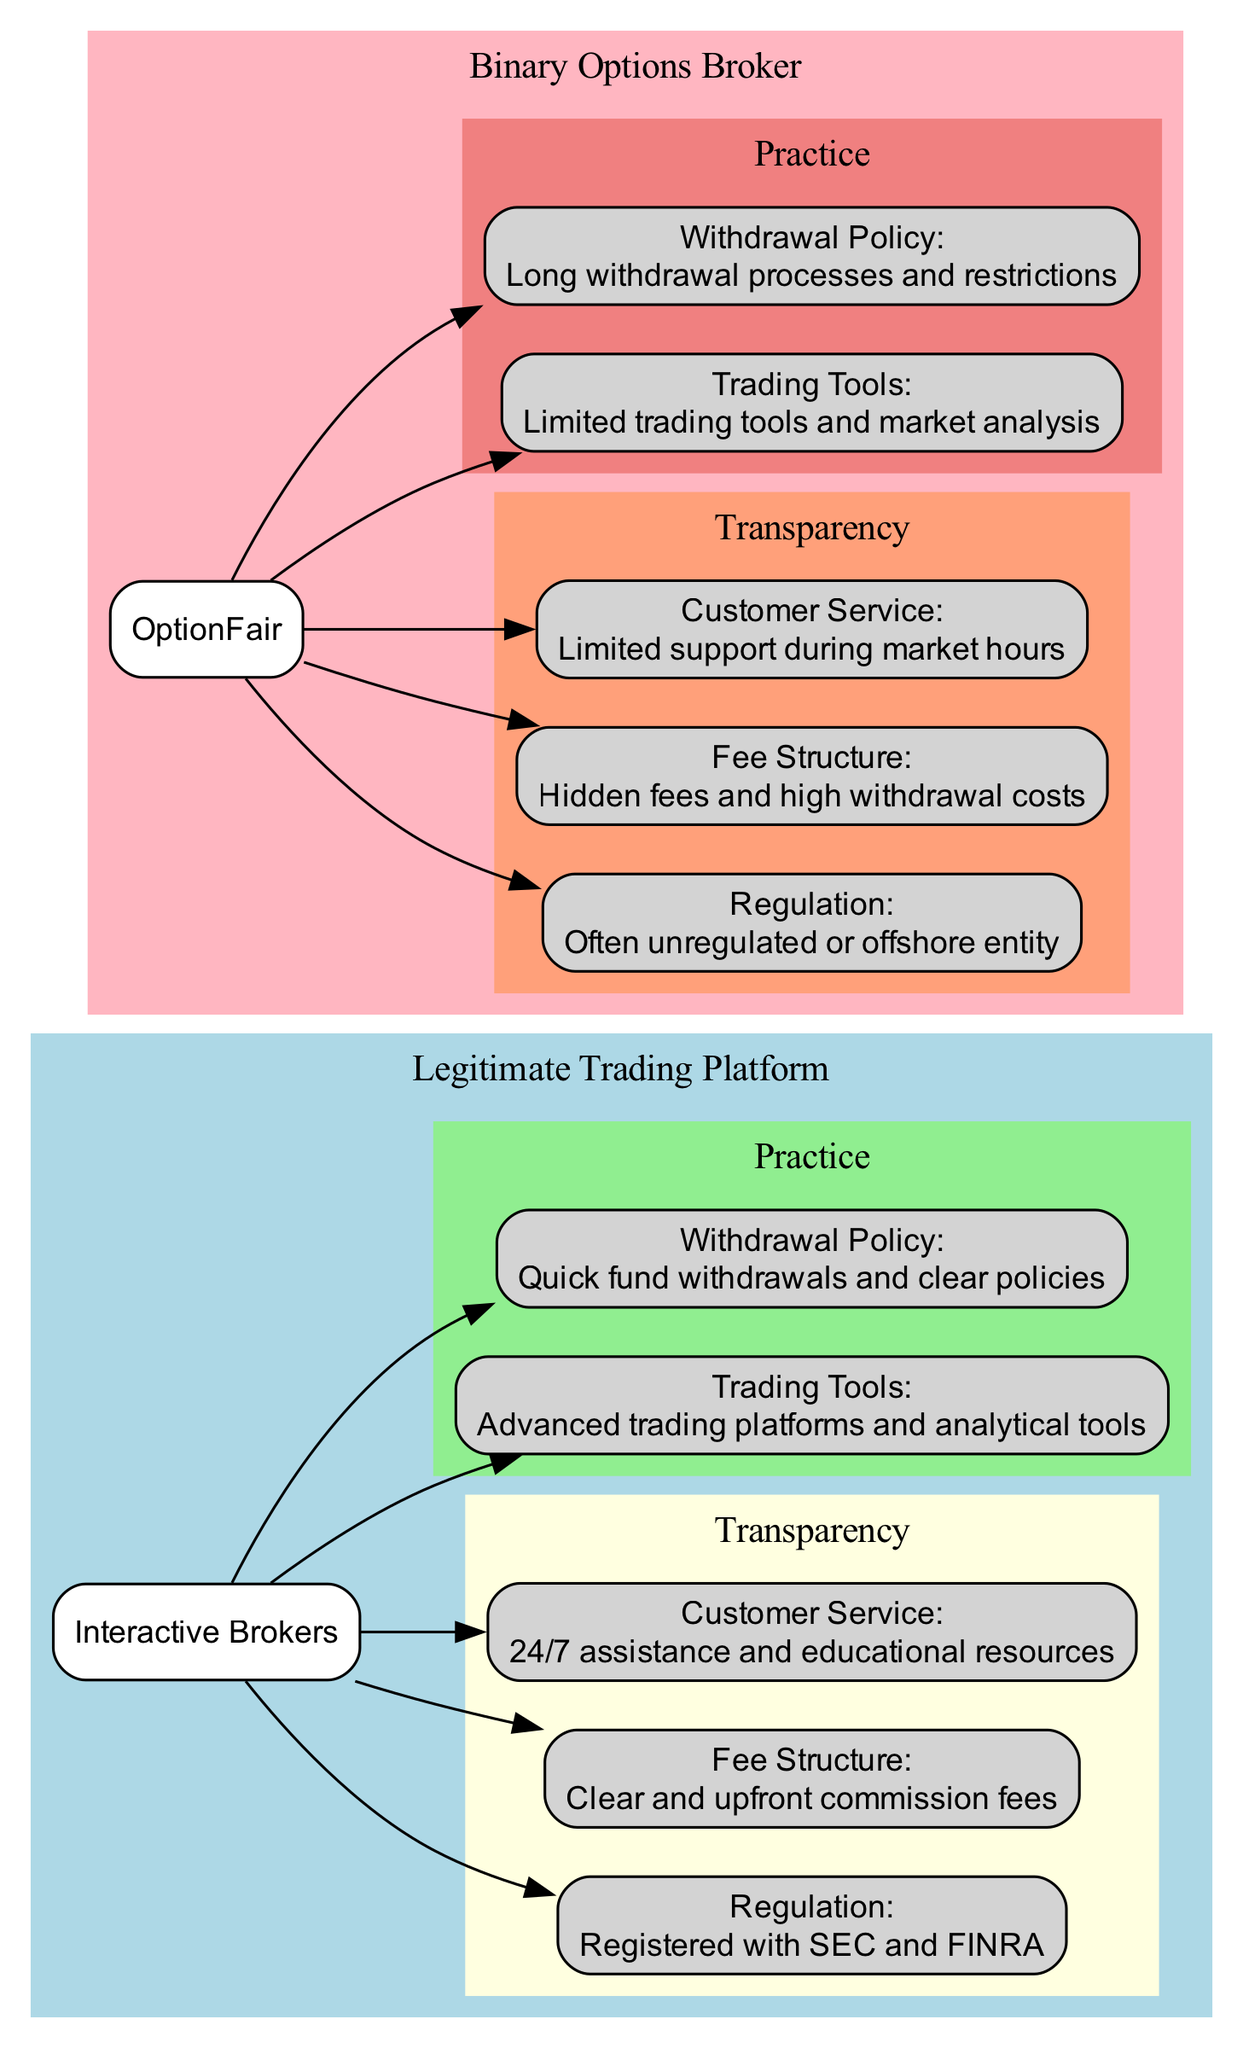What is the regulation status of Interactive Brokers? The diagram states that Interactive Brokers is "Registered with SEC and FINRA," which indicates that it adheres to strict regulatory oversight.
Answer: Registered with SEC and FINRA What type of customer service does OptionFair provide? According to the diagram, OptionFair has "Limited support during market hours," which implies that their customer service is not available round-the-clock.
Answer: Limited support during market hours How many transparency aspects are listed for each platform? The diagram displays three transparency aspects (Regulation, Fee Structure, Customer Service) for each type of platform, hence the total is six.
Answer: Three What is the difference in withdrawal policies between the two platforms? The withdrawal policy for Interactive Brokers states "Quick fund withdrawals and clear policies," while OptionFair states "Long withdrawal processes and restrictions." This shows a significant contrast in their withdrawal practices.
Answer: Quick fund withdrawals and clear policies vs Long withdrawal processes and restrictions Which platform has a clearer fee structure? The diagram indicates that Interactive Brokers has a "Clear and upfront commission fees," whereas OptionFair shows "Hidden fees and high withdrawal costs," therefore Interactive Brokers is the clear answer.
Answer: Interactive Brokers How do the trading tools of both platforms compare? The diagram shows "Advanced trading platforms and analytical tools" for Interactive Brokers, while it states "Limited trading tools and market analysis" for OptionFair. This suggests a substantial difference in the level of trading tools provided.
Answer: Advanced trading platforms and analytical tools vs Limited trading tools and market analysis What color represents the Binary Options Broker in the diagram? The diagram uses the color "lightpink" to represent the Binary Options Broker, which is distinctly different from the colors used for the Legitimate Trading Platform.
Answer: Lightpink Which platform is depicted as having better transparency? The elements illustrating Interactive Brokers emphasize their regulatory status and clear fee structure, while OptionFair lacks regulation and has hidden fees, indicating that Interactive Brokers is more transparent.
Answer: Interactive Brokers 